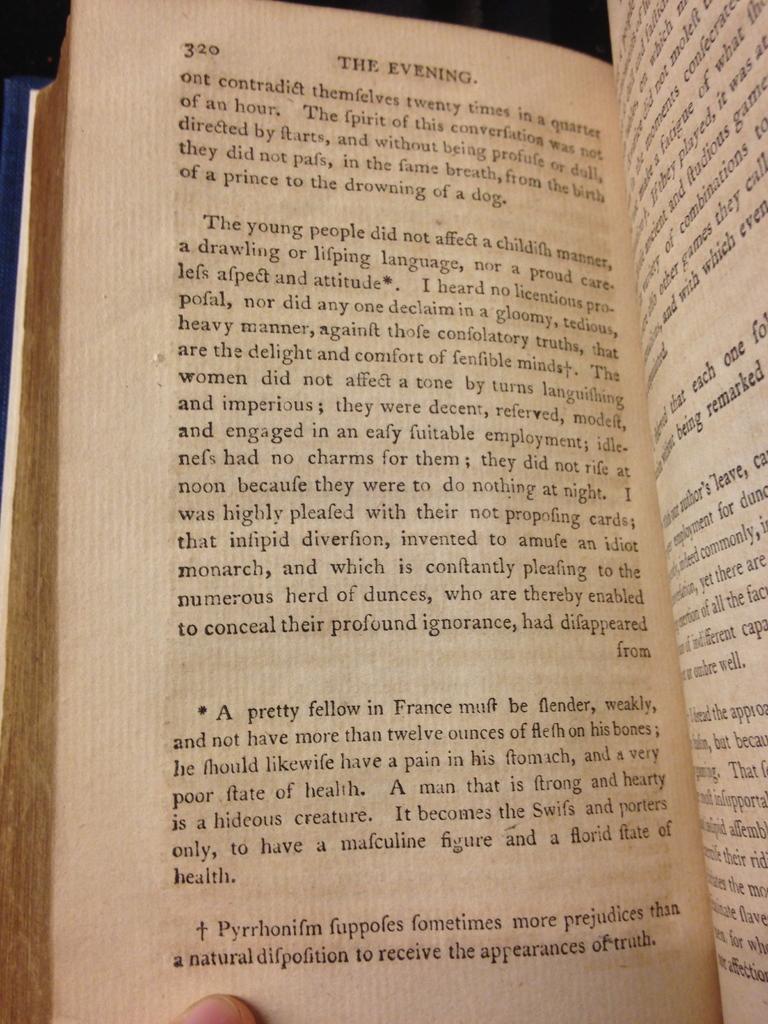How would you summarize this image in a sentence or two? In this image I can see there is the matter in the book. At the bottom it is the human finger. 